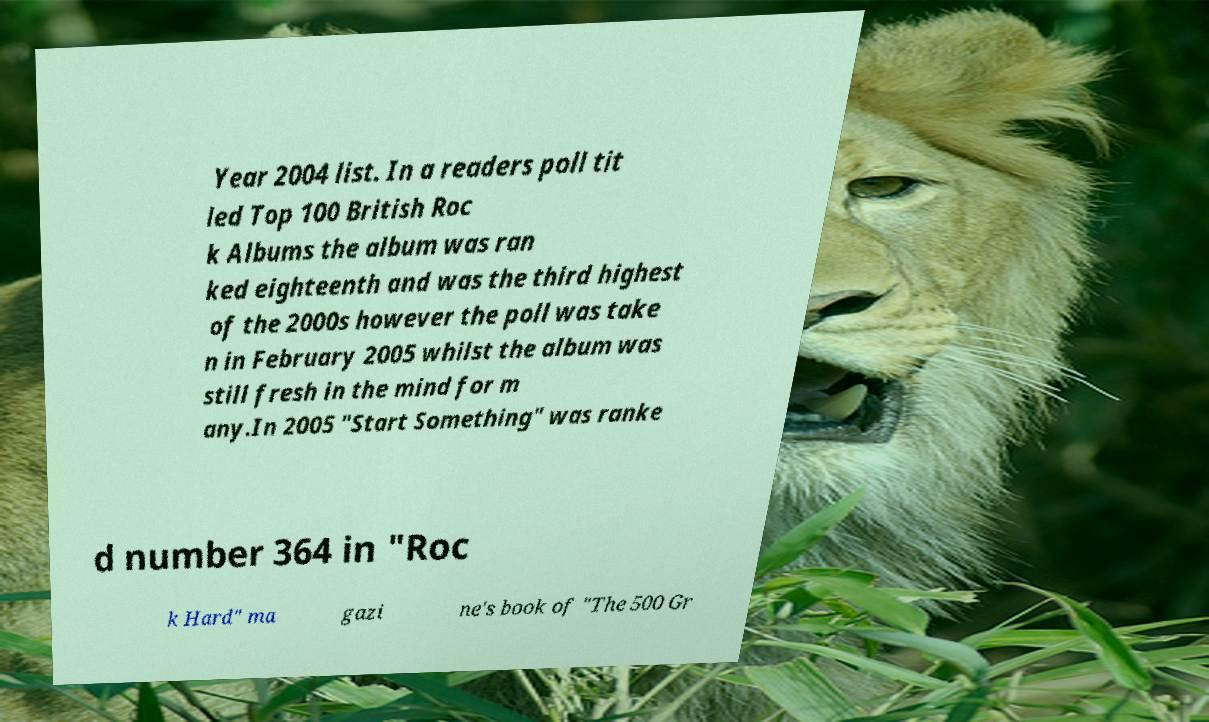Please identify and transcribe the text found in this image. Year 2004 list. In a readers poll tit led Top 100 British Roc k Albums the album was ran ked eighteenth and was the third highest of the 2000s however the poll was take n in February 2005 whilst the album was still fresh in the mind for m any.In 2005 "Start Something" was ranke d number 364 in "Roc k Hard" ma gazi ne's book of "The 500 Gr 